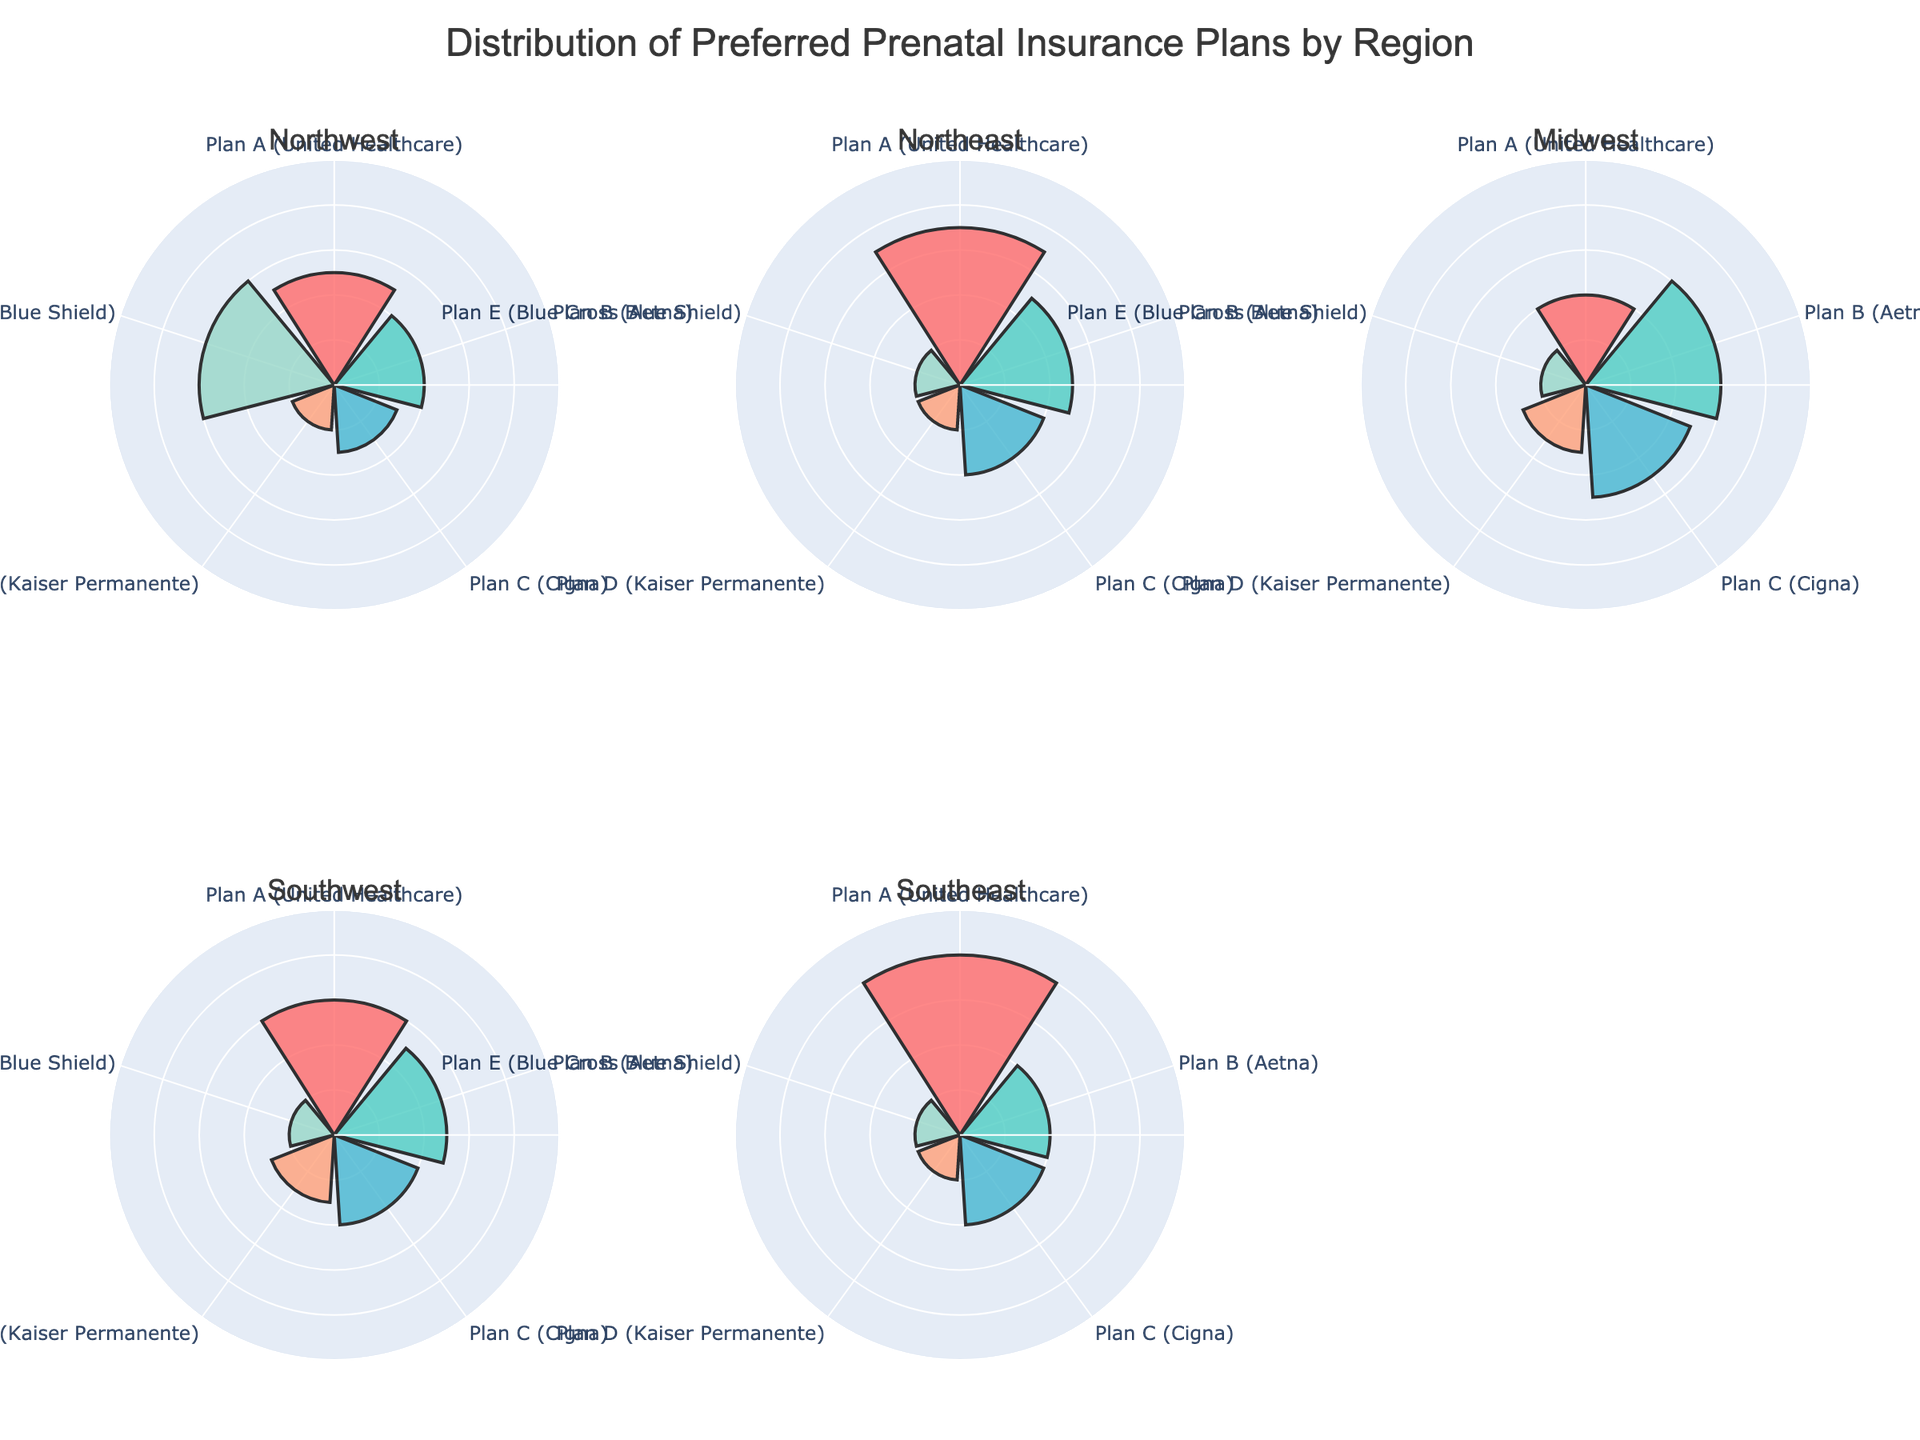Which insurance plan is the most preferred in the Northwest region? By looking at the Northwest subplot of the rose chart, the insurance plan with the largest segment is Plan E (Blue Cross Blue Shield) at 30%.
Answer: Plan E (Blue Cross Blue Shield) Which region has the highest percentage of mothers preferring Plan A (United Healthcare)? By comparing the Plan A (United Healthcare) segments across all regions, it is clear that the Southeast region has the highest preference at 40%.
Answer: Southeast What is the combined percentage of mothers preferring Plan B (Aetna) and Plan C (Cigna) in the Northeast region? In the Northeast subplot, Plan B (Aetna) is 25% and Plan C (Cigna) is 20%. Adding these percentages together gives 25% + 20% = 45%.
Answer: 45% Which region has the least variation in the distribution of preferred insurance plans? Observing the subplots, the Northeast region shows the least variation with more evenly distributed preferences: Plan A at 35%, Plan B at 25%, Plan C at 20%, Plan D at 10%, and Plan E at 10%.
Answer: Northeast Of the regions shown, which one has the lowest preference for Plan D (Kaiser Permanente)? By looking at the segments corresponding to Plan D (Kaiser Permanente), each region has 10% except for the Midwest which has 15%. Thus, tied with the other regions at 10%, no region shows significantly lower preference.
Answer: Tie among Northwest, Northeast, Southwest, and Southeast What is the average percentage for Plan E (Blue Cross Blue Shield) across all regions? Summing the percentages for Plan E (Blue Cross Blue Shield) from each region: 30% (Northwest) + 10% (Northeast) + 10% (Midwest) + 10% (Southwest) + 10% (Southeast) gives a total of 70%. Dividing by the 5 regions results in an average of 70/5 = 14%.
Answer: 14% Which region has the smallest segment for any insurance plan, and what is the percentage? Looking at all the subplots, the Northeast, Midwest, Southwest, and Southeast all have Plan D (Kaiser Permanente) and Plan E (Blue Cross Blue Shield) each at 10%, which is the smallest segment across any region.
Answer: 10%, multiple regions What's the difference in the percentage of mothers preferring Plan A (United Healthcare) between the Southeast and Midwest regions? Plan A (United Healthcare) in the Southeast is 40%, and in the Midwest is 20%. The difference is 40% - 20% = 20%.
Answer: 20% Which insurance plan has close to equal preference in at least two different regions? Plan C (Cigna) comes close in the Midwest and Southeast with 25% and 20% respectively, demonstrating close preference rates.
Answer: Plan C (Cigna) 